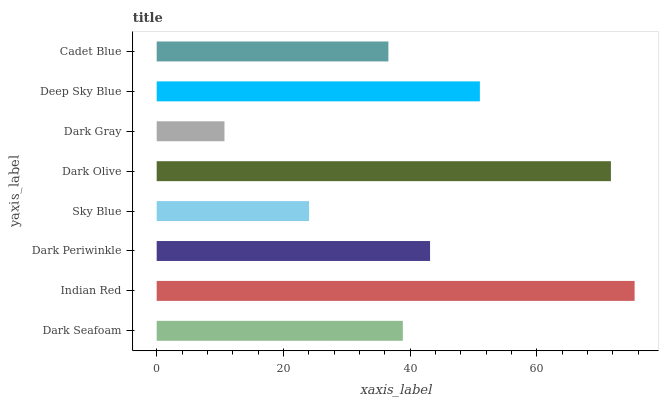Is Dark Gray the minimum?
Answer yes or no. Yes. Is Indian Red the maximum?
Answer yes or no. Yes. Is Dark Periwinkle the minimum?
Answer yes or no. No. Is Dark Periwinkle the maximum?
Answer yes or no. No. Is Indian Red greater than Dark Periwinkle?
Answer yes or no. Yes. Is Dark Periwinkle less than Indian Red?
Answer yes or no. Yes. Is Dark Periwinkle greater than Indian Red?
Answer yes or no. No. Is Indian Red less than Dark Periwinkle?
Answer yes or no. No. Is Dark Periwinkle the high median?
Answer yes or no. Yes. Is Dark Seafoam the low median?
Answer yes or no. Yes. Is Dark Olive the high median?
Answer yes or no. No. Is Dark Periwinkle the low median?
Answer yes or no. No. 